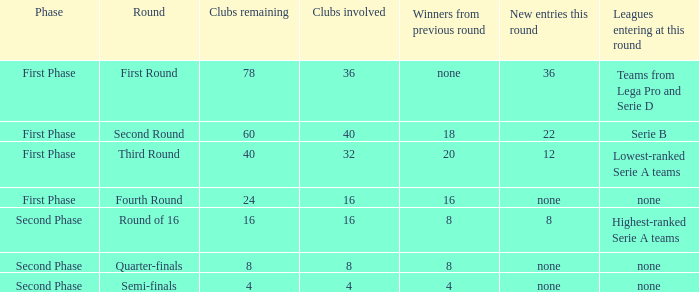In the initial stage with 16 clubs participating, who were the winners from the previous round? 16.0. 